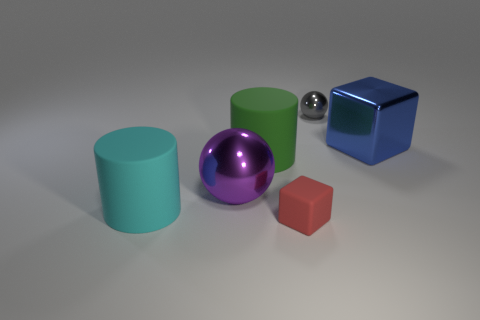The object that is both on the left side of the small red cube and in front of the big purple sphere is made of what material?
Provide a short and direct response. Rubber. There is a rubber cylinder behind the metallic ball in front of the shiny sphere that is right of the tiny red object; what is its color?
Make the answer very short. Green. The ball that is the same size as the red matte block is what color?
Your answer should be very brief. Gray. The large object that is right of the shiny sphere behind the large metallic cube is made of what material?
Give a very brief answer. Metal. What number of blocks are to the right of the small gray thing and in front of the purple ball?
Your answer should be very brief. 0. How many other objects are the same size as the blue object?
Offer a very short reply. 3. Does the small object in front of the large blue shiny object have the same shape as the metal object that is left of the tiny block?
Ensure brevity in your answer.  No. Are there any cyan cylinders in front of the blue metal block?
Give a very brief answer. Yes. The other rubber thing that is the same shape as the large blue object is what color?
Your answer should be compact. Red. What is the material of the cube on the left side of the big block?
Keep it short and to the point. Rubber. 